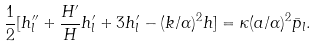<formula> <loc_0><loc_0><loc_500><loc_500>\frac { 1 } { 2 } [ h _ { l } ^ { \prime \prime } + \frac { H ^ { \prime } } { H } h _ { l } ^ { \prime } + 3 h _ { l } ^ { \prime } - ( k / \alpha ) ^ { 2 } h ] = \kappa ( a / \alpha ) ^ { 2 } \bar { p } _ { l } .</formula> 